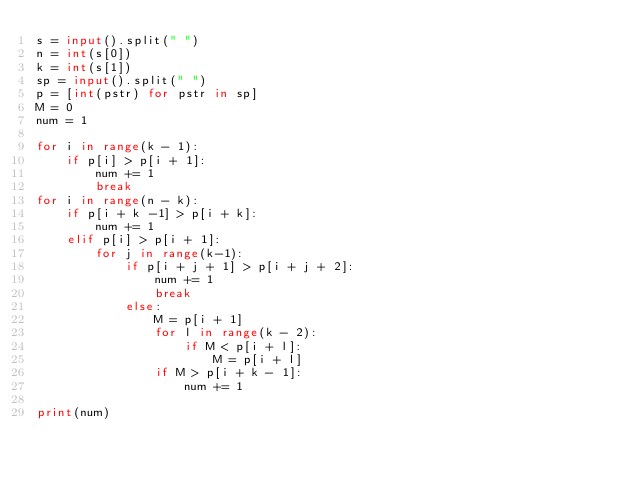<code> <loc_0><loc_0><loc_500><loc_500><_Python_>s = input().split(" ")
n = int(s[0])
k = int(s[1])
sp = input().split(" ")
p = [int(pstr) for pstr in sp]
M = 0
num = 1

for i in range(k - 1):
    if p[i] > p[i + 1]:
        num += 1
        break   
for i in range(n - k):
    if p[i + k -1] > p[i + k]:
        num += 1
    elif p[i] > p[i + 1]:
        for j in range(k-1):
            if p[i + j + 1] > p[i + j + 2]:
                num += 1
                break
            else:
                M = p[i + 1]
                for l in range(k - 2):
                    if M < p[i + l]:
                        M = p[i + l]
                if M > p[i + k - 1]:
                    num += 1

print(num)</code> 